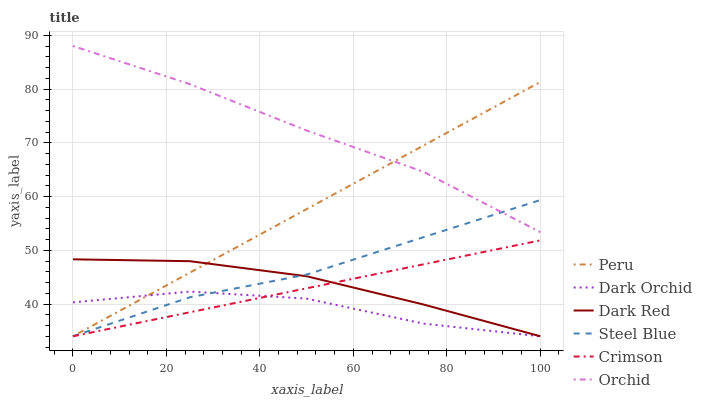Does Steel Blue have the minimum area under the curve?
Answer yes or no. No. Does Steel Blue have the maximum area under the curve?
Answer yes or no. No. Is Steel Blue the smoothest?
Answer yes or no. No. Is Steel Blue the roughest?
Answer yes or no. No. Does Orchid have the lowest value?
Answer yes or no. No. Does Steel Blue have the highest value?
Answer yes or no. No. Is Dark Red less than Orchid?
Answer yes or no. Yes. Is Orchid greater than Crimson?
Answer yes or no. Yes. Does Dark Red intersect Orchid?
Answer yes or no. No. 